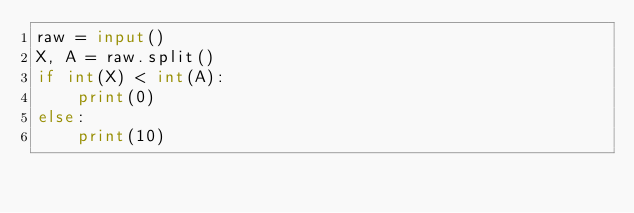<code> <loc_0><loc_0><loc_500><loc_500><_Python_>raw = input()
X, A = raw.split()
if int(X) < int(A):
    print(0)
else:
    print(10)</code> 